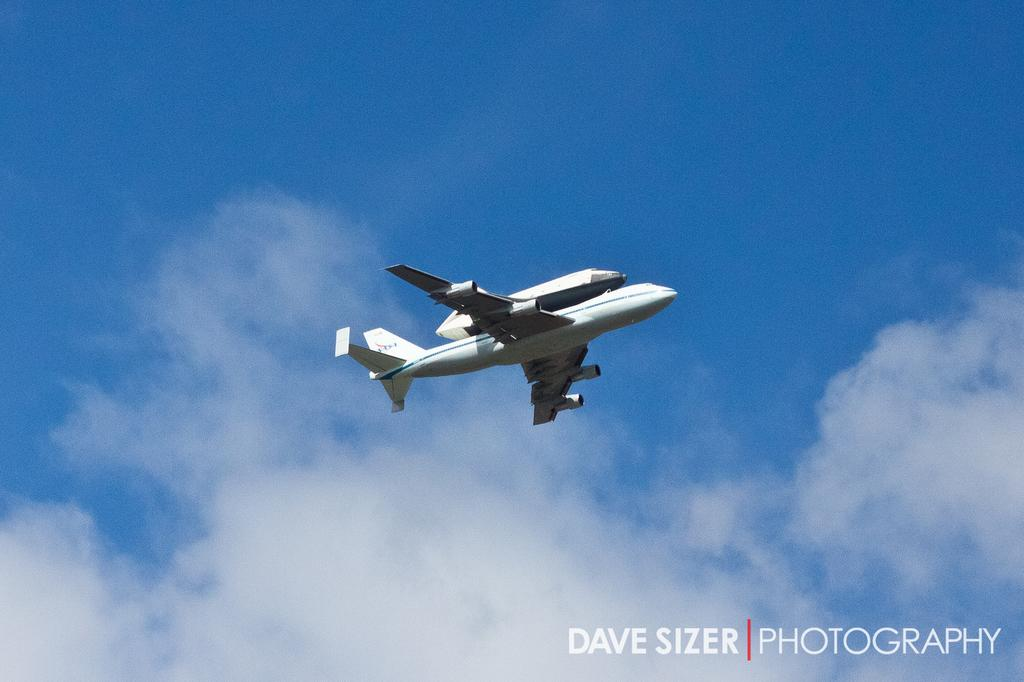What is the main subject in the foreground of the image? There is an airplane in the foreground of the image. What is the airplane's position in the image? The airplane is in the air. What can be seen in the background of the image? There is the sky visible in the background of the image. What is the condition of the sky in the image? There are clouds in the sky. What type of feather can be seen falling from the sky in the image? There is no feather falling from the sky in the image; it only features an airplane and clouds in the sky. 